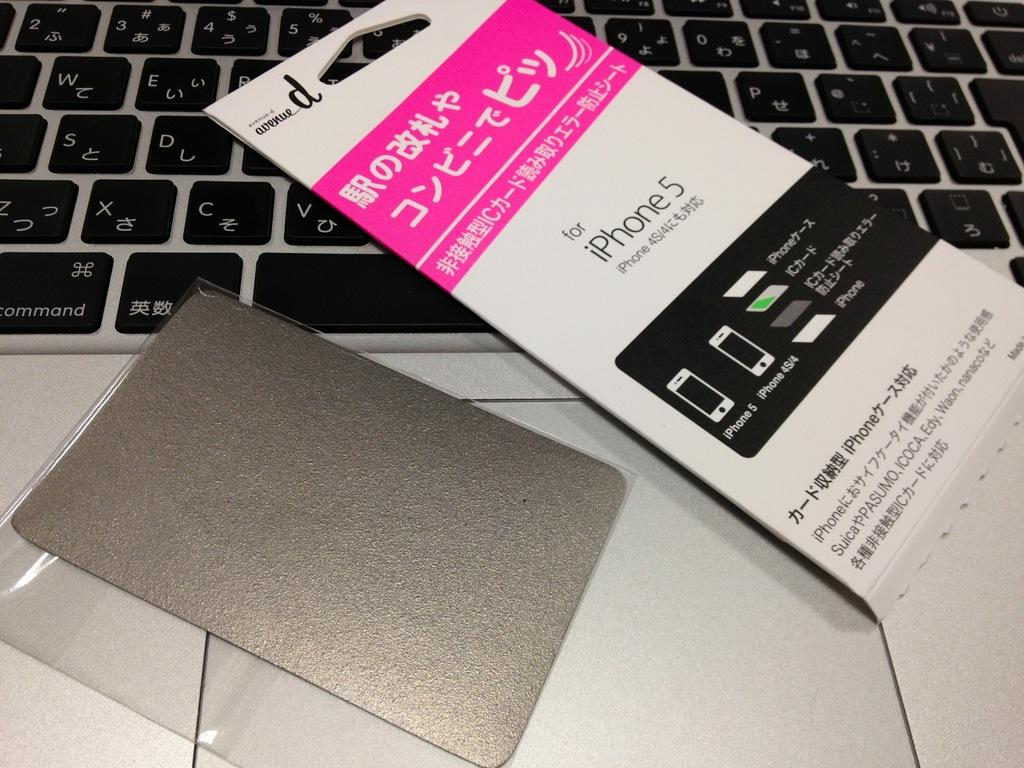<image>
Relay a brief, clear account of the picture shown. an ad for iPhone 5 and Japanese letters 